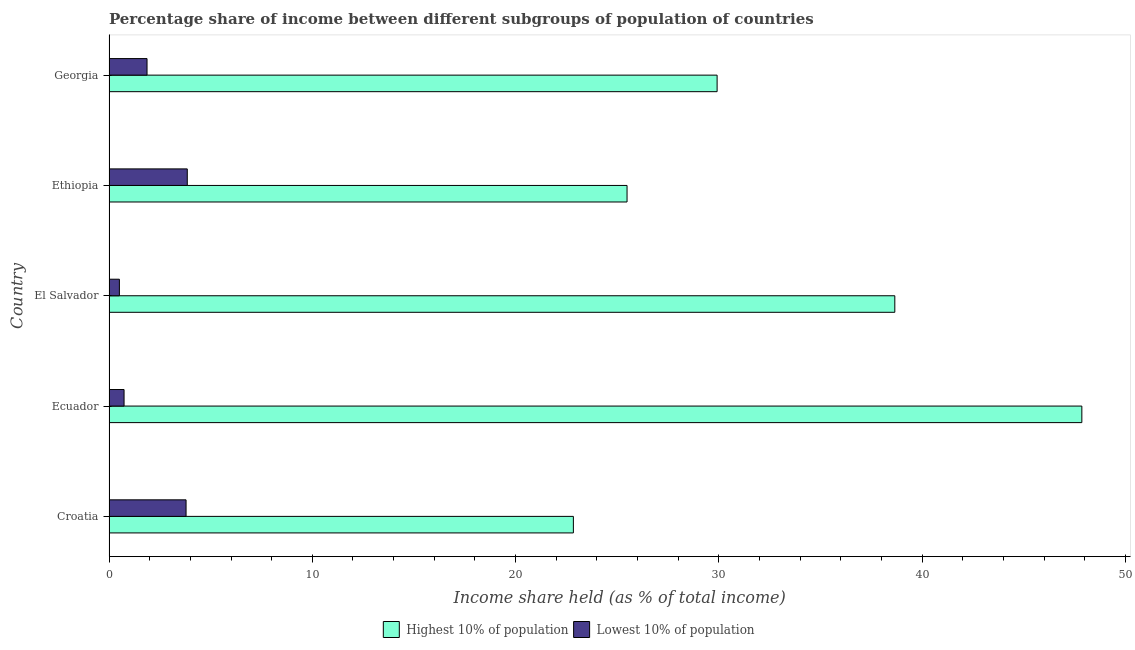How many groups of bars are there?
Offer a very short reply. 5. Are the number of bars on each tick of the Y-axis equal?
Keep it short and to the point. Yes. What is the label of the 5th group of bars from the top?
Keep it short and to the point. Croatia. What is the income share held by lowest 10% of the population in Croatia?
Keep it short and to the point. 3.79. Across all countries, what is the maximum income share held by lowest 10% of the population?
Ensure brevity in your answer.  3.85. Across all countries, what is the minimum income share held by highest 10% of the population?
Offer a very short reply. 22.84. In which country was the income share held by highest 10% of the population maximum?
Give a very brief answer. Ecuador. In which country was the income share held by highest 10% of the population minimum?
Give a very brief answer. Croatia. What is the total income share held by highest 10% of the population in the graph?
Ensure brevity in your answer.  164.73. What is the difference between the income share held by highest 10% of the population in Croatia and that in El Salvador?
Provide a succinct answer. -15.81. What is the difference between the income share held by lowest 10% of the population in Ecuador and the income share held by highest 10% of the population in Croatia?
Provide a short and direct response. -22.1. What is the average income share held by highest 10% of the population per country?
Make the answer very short. 32.95. What is the difference between the income share held by lowest 10% of the population and income share held by highest 10% of the population in Ecuador?
Give a very brief answer. -47.11. What is the ratio of the income share held by lowest 10% of the population in Ecuador to that in El Salvador?
Make the answer very short. 1.45. Is the income share held by highest 10% of the population in El Salvador less than that in Ethiopia?
Give a very brief answer. No. Is the difference between the income share held by highest 10% of the population in Ethiopia and Georgia greater than the difference between the income share held by lowest 10% of the population in Ethiopia and Georgia?
Provide a succinct answer. No. What is the difference between the highest and the lowest income share held by lowest 10% of the population?
Your answer should be compact. 3.34. In how many countries, is the income share held by highest 10% of the population greater than the average income share held by highest 10% of the population taken over all countries?
Your answer should be very brief. 2. What does the 2nd bar from the top in El Salvador represents?
Provide a short and direct response. Highest 10% of population. What does the 1st bar from the bottom in Croatia represents?
Provide a succinct answer. Highest 10% of population. Does the graph contain any zero values?
Give a very brief answer. No. Does the graph contain grids?
Make the answer very short. No. How many legend labels are there?
Offer a very short reply. 2. What is the title of the graph?
Your answer should be compact. Percentage share of income between different subgroups of population of countries. What is the label or title of the X-axis?
Provide a short and direct response. Income share held (as % of total income). What is the Income share held (as % of total income) of Highest 10% of population in Croatia?
Offer a very short reply. 22.84. What is the Income share held (as % of total income) in Lowest 10% of population in Croatia?
Provide a short and direct response. 3.79. What is the Income share held (as % of total income) of Highest 10% of population in Ecuador?
Offer a terse response. 47.85. What is the Income share held (as % of total income) in Lowest 10% of population in Ecuador?
Provide a succinct answer. 0.74. What is the Income share held (as % of total income) in Highest 10% of population in El Salvador?
Offer a terse response. 38.65. What is the Income share held (as % of total income) of Lowest 10% of population in El Salvador?
Ensure brevity in your answer.  0.51. What is the Income share held (as % of total income) in Highest 10% of population in Ethiopia?
Your answer should be compact. 25.48. What is the Income share held (as % of total income) in Lowest 10% of population in Ethiopia?
Your answer should be compact. 3.85. What is the Income share held (as % of total income) in Highest 10% of population in Georgia?
Your response must be concise. 29.91. What is the Income share held (as % of total income) of Lowest 10% of population in Georgia?
Your answer should be compact. 1.87. Across all countries, what is the maximum Income share held (as % of total income) of Highest 10% of population?
Provide a short and direct response. 47.85. Across all countries, what is the maximum Income share held (as % of total income) in Lowest 10% of population?
Keep it short and to the point. 3.85. Across all countries, what is the minimum Income share held (as % of total income) in Highest 10% of population?
Offer a very short reply. 22.84. Across all countries, what is the minimum Income share held (as % of total income) of Lowest 10% of population?
Provide a short and direct response. 0.51. What is the total Income share held (as % of total income) in Highest 10% of population in the graph?
Keep it short and to the point. 164.73. What is the total Income share held (as % of total income) in Lowest 10% of population in the graph?
Your answer should be compact. 10.76. What is the difference between the Income share held (as % of total income) of Highest 10% of population in Croatia and that in Ecuador?
Your response must be concise. -25.01. What is the difference between the Income share held (as % of total income) of Lowest 10% of population in Croatia and that in Ecuador?
Offer a terse response. 3.05. What is the difference between the Income share held (as % of total income) of Highest 10% of population in Croatia and that in El Salvador?
Provide a succinct answer. -15.81. What is the difference between the Income share held (as % of total income) of Lowest 10% of population in Croatia and that in El Salvador?
Your response must be concise. 3.28. What is the difference between the Income share held (as % of total income) of Highest 10% of population in Croatia and that in Ethiopia?
Provide a short and direct response. -2.64. What is the difference between the Income share held (as % of total income) of Lowest 10% of population in Croatia and that in Ethiopia?
Offer a terse response. -0.06. What is the difference between the Income share held (as % of total income) of Highest 10% of population in Croatia and that in Georgia?
Make the answer very short. -7.07. What is the difference between the Income share held (as % of total income) of Lowest 10% of population in Croatia and that in Georgia?
Ensure brevity in your answer.  1.92. What is the difference between the Income share held (as % of total income) of Highest 10% of population in Ecuador and that in El Salvador?
Make the answer very short. 9.2. What is the difference between the Income share held (as % of total income) in Lowest 10% of population in Ecuador and that in El Salvador?
Offer a terse response. 0.23. What is the difference between the Income share held (as % of total income) of Highest 10% of population in Ecuador and that in Ethiopia?
Keep it short and to the point. 22.37. What is the difference between the Income share held (as % of total income) in Lowest 10% of population in Ecuador and that in Ethiopia?
Offer a terse response. -3.11. What is the difference between the Income share held (as % of total income) in Highest 10% of population in Ecuador and that in Georgia?
Your response must be concise. 17.94. What is the difference between the Income share held (as % of total income) in Lowest 10% of population in Ecuador and that in Georgia?
Your response must be concise. -1.13. What is the difference between the Income share held (as % of total income) of Highest 10% of population in El Salvador and that in Ethiopia?
Your answer should be compact. 13.17. What is the difference between the Income share held (as % of total income) of Lowest 10% of population in El Salvador and that in Ethiopia?
Keep it short and to the point. -3.34. What is the difference between the Income share held (as % of total income) in Highest 10% of population in El Salvador and that in Georgia?
Your answer should be very brief. 8.74. What is the difference between the Income share held (as % of total income) of Lowest 10% of population in El Salvador and that in Georgia?
Offer a very short reply. -1.36. What is the difference between the Income share held (as % of total income) of Highest 10% of population in Ethiopia and that in Georgia?
Give a very brief answer. -4.43. What is the difference between the Income share held (as % of total income) of Lowest 10% of population in Ethiopia and that in Georgia?
Your answer should be compact. 1.98. What is the difference between the Income share held (as % of total income) in Highest 10% of population in Croatia and the Income share held (as % of total income) in Lowest 10% of population in Ecuador?
Keep it short and to the point. 22.1. What is the difference between the Income share held (as % of total income) of Highest 10% of population in Croatia and the Income share held (as % of total income) of Lowest 10% of population in El Salvador?
Provide a succinct answer. 22.33. What is the difference between the Income share held (as % of total income) of Highest 10% of population in Croatia and the Income share held (as % of total income) of Lowest 10% of population in Ethiopia?
Offer a very short reply. 18.99. What is the difference between the Income share held (as % of total income) in Highest 10% of population in Croatia and the Income share held (as % of total income) in Lowest 10% of population in Georgia?
Your answer should be very brief. 20.97. What is the difference between the Income share held (as % of total income) of Highest 10% of population in Ecuador and the Income share held (as % of total income) of Lowest 10% of population in El Salvador?
Your response must be concise. 47.34. What is the difference between the Income share held (as % of total income) of Highest 10% of population in Ecuador and the Income share held (as % of total income) of Lowest 10% of population in Georgia?
Your response must be concise. 45.98. What is the difference between the Income share held (as % of total income) of Highest 10% of population in El Salvador and the Income share held (as % of total income) of Lowest 10% of population in Ethiopia?
Your answer should be very brief. 34.8. What is the difference between the Income share held (as % of total income) in Highest 10% of population in El Salvador and the Income share held (as % of total income) in Lowest 10% of population in Georgia?
Ensure brevity in your answer.  36.78. What is the difference between the Income share held (as % of total income) in Highest 10% of population in Ethiopia and the Income share held (as % of total income) in Lowest 10% of population in Georgia?
Make the answer very short. 23.61. What is the average Income share held (as % of total income) in Highest 10% of population per country?
Ensure brevity in your answer.  32.95. What is the average Income share held (as % of total income) in Lowest 10% of population per country?
Offer a terse response. 2.15. What is the difference between the Income share held (as % of total income) in Highest 10% of population and Income share held (as % of total income) in Lowest 10% of population in Croatia?
Offer a very short reply. 19.05. What is the difference between the Income share held (as % of total income) of Highest 10% of population and Income share held (as % of total income) of Lowest 10% of population in Ecuador?
Give a very brief answer. 47.11. What is the difference between the Income share held (as % of total income) of Highest 10% of population and Income share held (as % of total income) of Lowest 10% of population in El Salvador?
Your answer should be compact. 38.14. What is the difference between the Income share held (as % of total income) in Highest 10% of population and Income share held (as % of total income) in Lowest 10% of population in Ethiopia?
Your response must be concise. 21.63. What is the difference between the Income share held (as % of total income) in Highest 10% of population and Income share held (as % of total income) in Lowest 10% of population in Georgia?
Offer a very short reply. 28.04. What is the ratio of the Income share held (as % of total income) in Highest 10% of population in Croatia to that in Ecuador?
Offer a terse response. 0.48. What is the ratio of the Income share held (as % of total income) in Lowest 10% of population in Croatia to that in Ecuador?
Keep it short and to the point. 5.12. What is the ratio of the Income share held (as % of total income) in Highest 10% of population in Croatia to that in El Salvador?
Provide a succinct answer. 0.59. What is the ratio of the Income share held (as % of total income) in Lowest 10% of population in Croatia to that in El Salvador?
Keep it short and to the point. 7.43. What is the ratio of the Income share held (as % of total income) of Highest 10% of population in Croatia to that in Ethiopia?
Provide a short and direct response. 0.9. What is the ratio of the Income share held (as % of total income) of Lowest 10% of population in Croatia to that in Ethiopia?
Give a very brief answer. 0.98. What is the ratio of the Income share held (as % of total income) in Highest 10% of population in Croatia to that in Georgia?
Your answer should be compact. 0.76. What is the ratio of the Income share held (as % of total income) in Lowest 10% of population in Croatia to that in Georgia?
Give a very brief answer. 2.03. What is the ratio of the Income share held (as % of total income) in Highest 10% of population in Ecuador to that in El Salvador?
Give a very brief answer. 1.24. What is the ratio of the Income share held (as % of total income) of Lowest 10% of population in Ecuador to that in El Salvador?
Your answer should be very brief. 1.45. What is the ratio of the Income share held (as % of total income) in Highest 10% of population in Ecuador to that in Ethiopia?
Give a very brief answer. 1.88. What is the ratio of the Income share held (as % of total income) in Lowest 10% of population in Ecuador to that in Ethiopia?
Give a very brief answer. 0.19. What is the ratio of the Income share held (as % of total income) in Highest 10% of population in Ecuador to that in Georgia?
Your answer should be very brief. 1.6. What is the ratio of the Income share held (as % of total income) of Lowest 10% of population in Ecuador to that in Georgia?
Your response must be concise. 0.4. What is the ratio of the Income share held (as % of total income) of Highest 10% of population in El Salvador to that in Ethiopia?
Ensure brevity in your answer.  1.52. What is the ratio of the Income share held (as % of total income) of Lowest 10% of population in El Salvador to that in Ethiopia?
Your answer should be very brief. 0.13. What is the ratio of the Income share held (as % of total income) of Highest 10% of population in El Salvador to that in Georgia?
Ensure brevity in your answer.  1.29. What is the ratio of the Income share held (as % of total income) in Lowest 10% of population in El Salvador to that in Georgia?
Provide a short and direct response. 0.27. What is the ratio of the Income share held (as % of total income) in Highest 10% of population in Ethiopia to that in Georgia?
Make the answer very short. 0.85. What is the ratio of the Income share held (as % of total income) of Lowest 10% of population in Ethiopia to that in Georgia?
Your response must be concise. 2.06. What is the difference between the highest and the second highest Income share held (as % of total income) in Lowest 10% of population?
Your answer should be compact. 0.06. What is the difference between the highest and the lowest Income share held (as % of total income) of Highest 10% of population?
Offer a terse response. 25.01. What is the difference between the highest and the lowest Income share held (as % of total income) in Lowest 10% of population?
Offer a terse response. 3.34. 